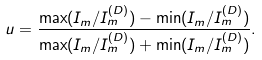Convert formula to latex. <formula><loc_0><loc_0><loc_500><loc_500>u = \frac { \max ( I _ { m } / I ^ { ( D ) } _ { m } ) - \min ( I _ { m } / I ^ { ( D ) } _ { m } ) } { \max ( I _ { m } / I ^ { ( D ) } _ { m } ) + \min ( I _ { m } / I ^ { ( D ) } _ { m } ) } .</formula> 